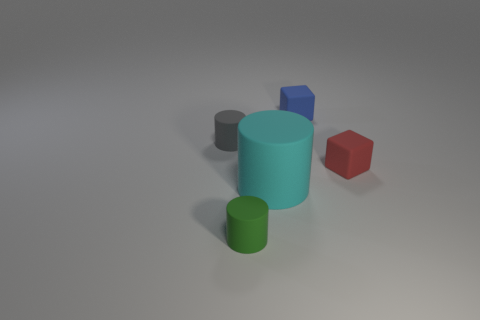Add 3 blue rubber blocks. How many objects exist? 8 Subtract all blocks. How many objects are left? 3 Add 1 blue objects. How many blue objects are left? 2 Add 2 cyan objects. How many cyan objects exist? 3 Subtract 0 blue spheres. How many objects are left? 5 Subtract all tiny red objects. Subtract all gray matte objects. How many objects are left? 3 